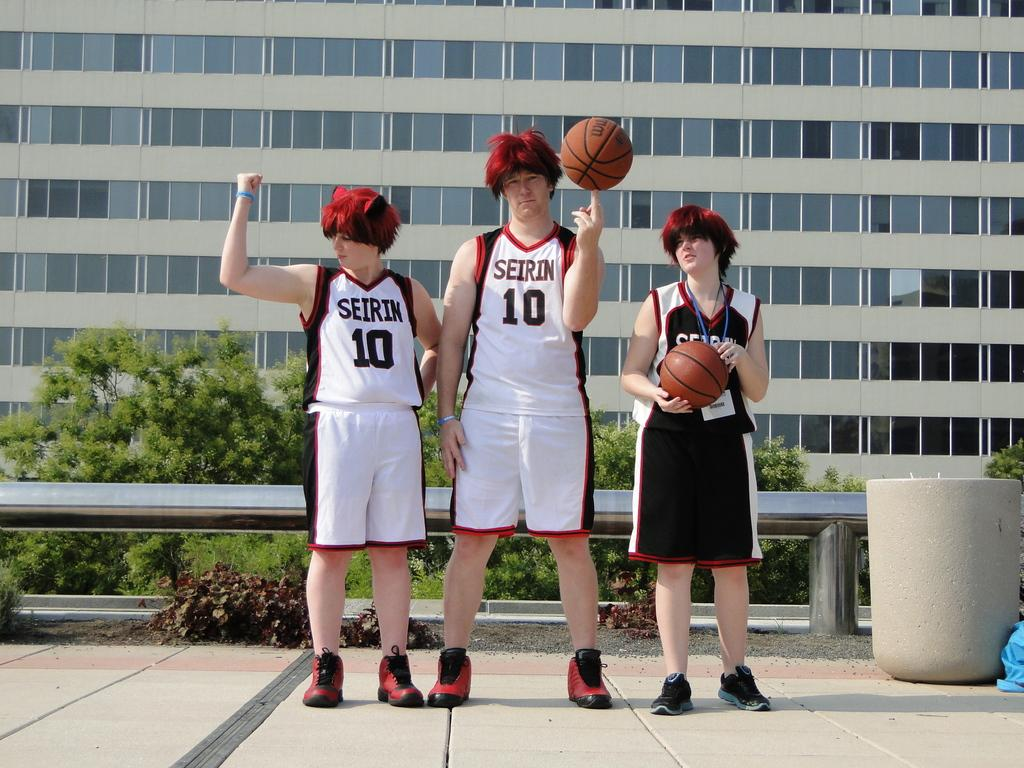<image>
Provide a brief description of the given image. 3 kids in basketball outfits with the jersey number 10 